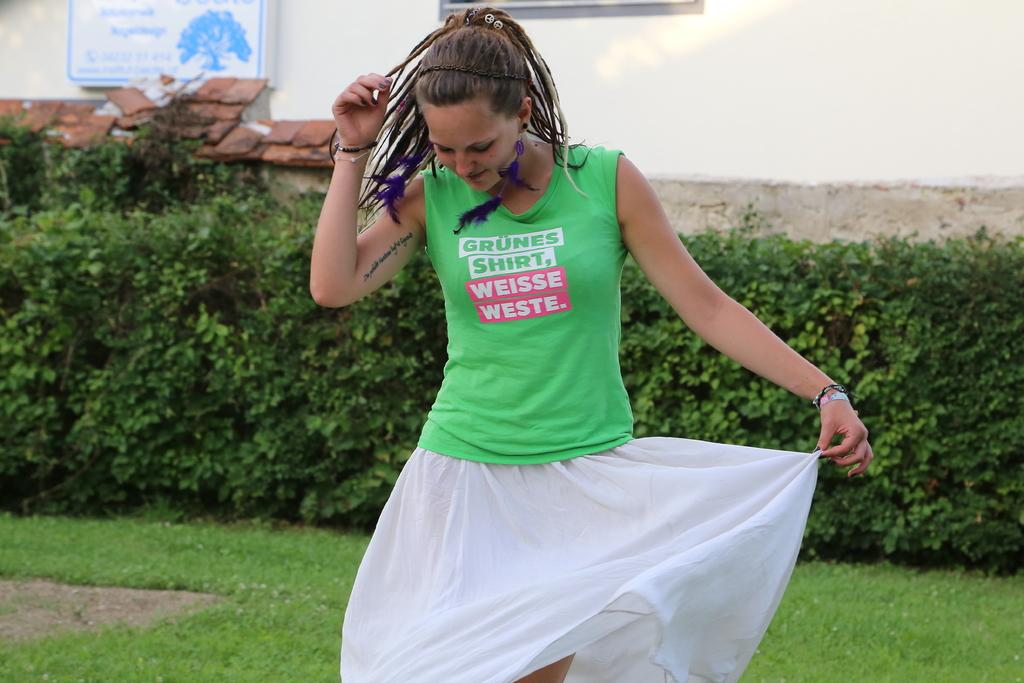Who is the main subject in the image? There is a woman in the image. What is the woman wearing? The woman is wearing a green t-shirt and a white skirt. Where is the woman standing? The woman is standing in front of a building. What can be seen in the background of the image? There are plants and another building in the background of the image. What object is present in the image? There is a board present in the image. What type of grape is the woman holding in the image? There is no grape present in the image; the woman is not holding any object. Who is the creator of the plants in the background of the image? The image does not provide information about the creator of the plants in the background. 